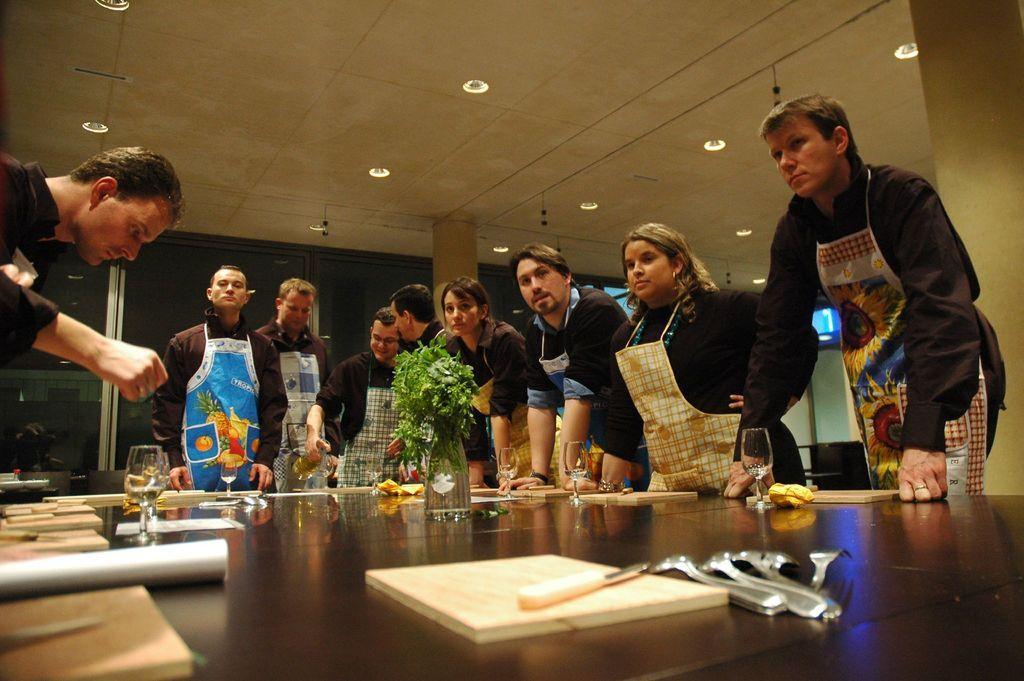How would you summarize this image in a sentence or two? In this image we can see this people are wearing apron and standing near the tables. There are glasses, spoons, forks, flower vase placed on the table. In the background we can see glass windows and ceiling with lights. 